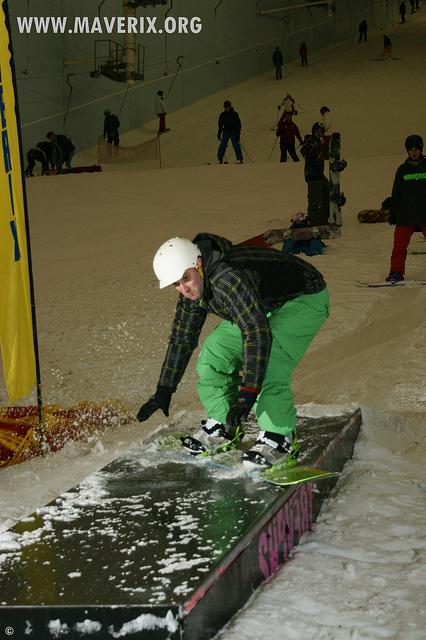What is the man doing?
Give a very brief answer. Snowboarding. What color are his pants?
Keep it brief. Green. Is the man scared?
Answer briefly. No. 